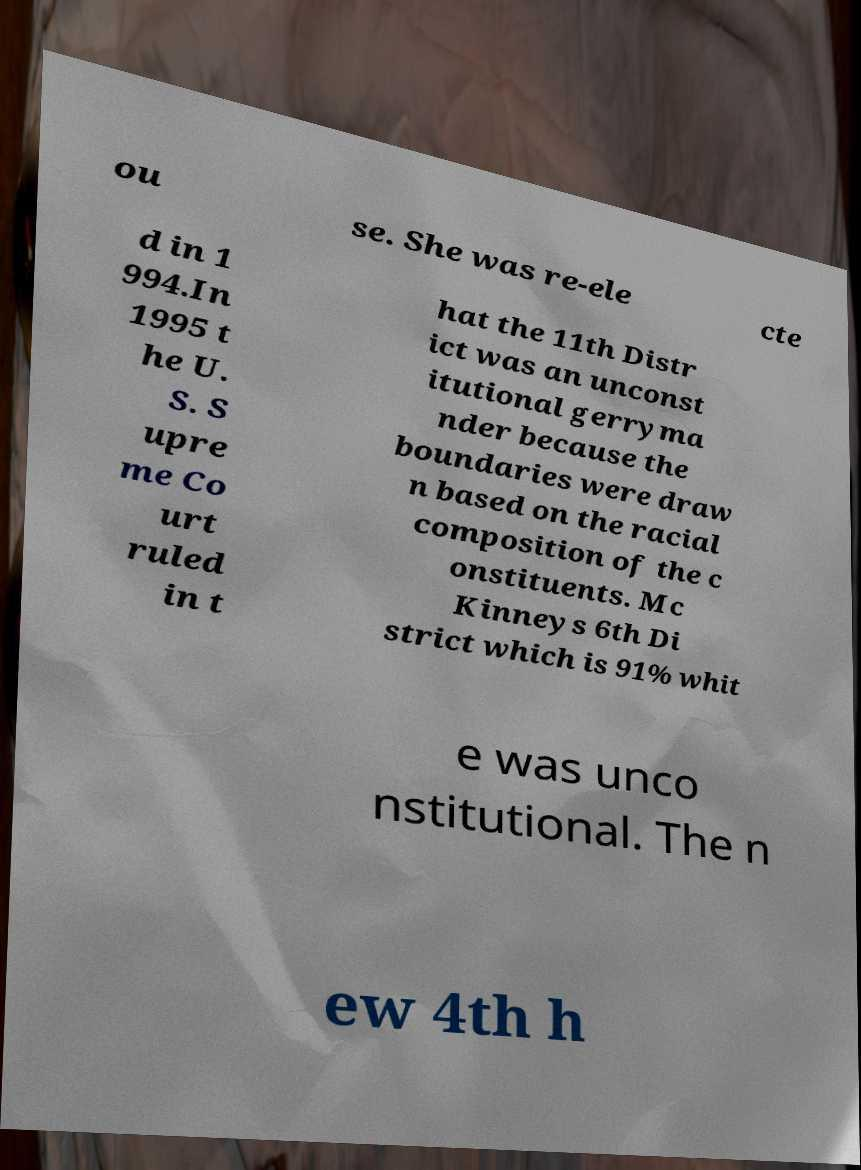Can you accurately transcribe the text from the provided image for me? ou se. She was re-ele cte d in 1 994.In 1995 t he U. S. S upre me Co urt ruled in t hat the 11th Distr ict was an unconst itutional gerryma nder because the boundaries were draw n based on the racial composition of the c onstituents. Mc Kinneys 6th Di strict which is 91% whit e was unco nstitutional. The n ew 4th h 